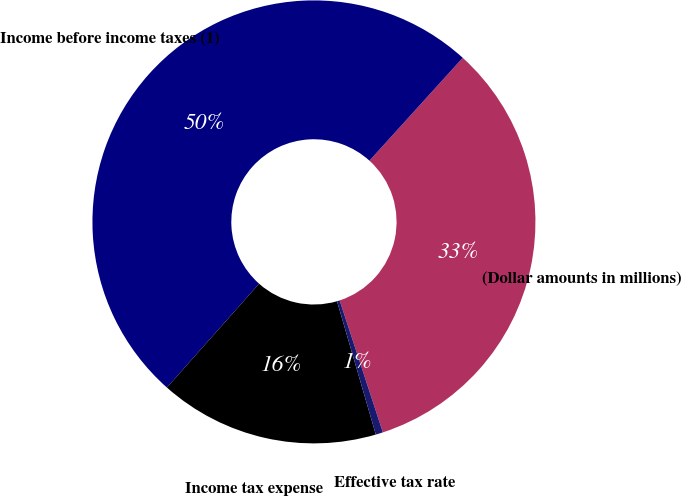<chart> <loc_0><loc_0><loc_500><loc_500><pie_chart><fcel>(Dollar amounts in millions)<fcel>Income before income taxes (1)<fcel>Income tax expense<fcel>Effective tax rate<nl><fcel>33.24%<fcel>50.17%<fcel>16.06%<fcel>0.53%<nl></chart> 